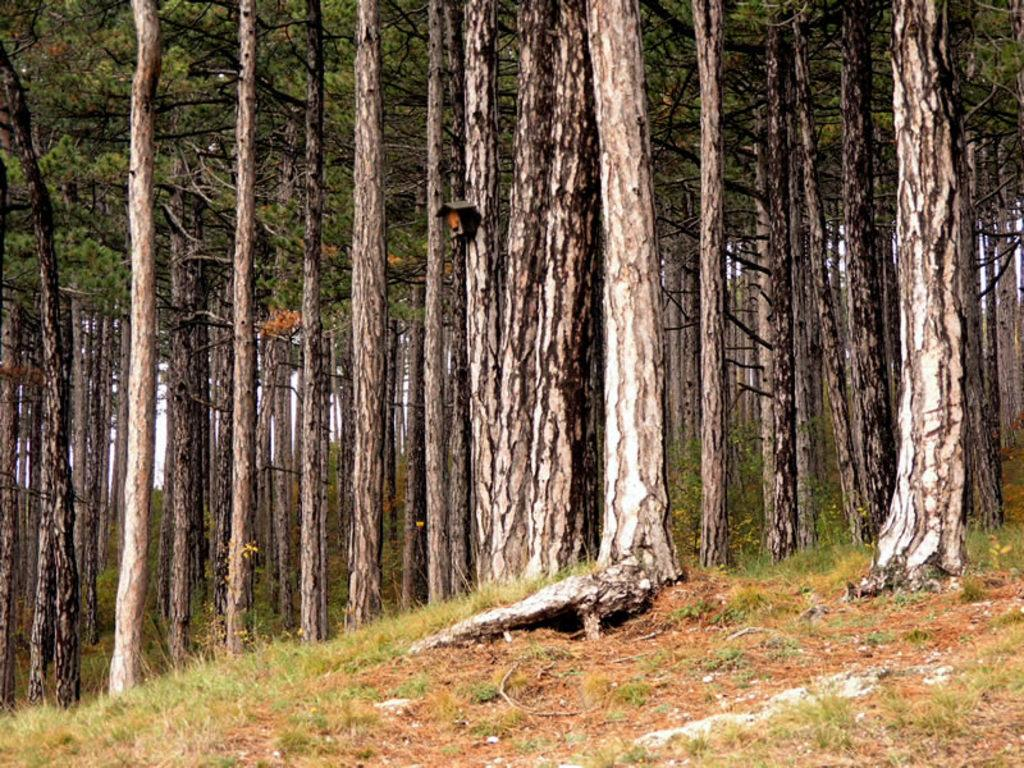What type of vegetation can be seen in the image? There is grass and trees in the image. Can you describe the natural environment depicted in the image? The image features grass and trees, which suggests a natural outdoor setting. What type of furniture is visible in the image? There is no furniture present in the image; it features grass and trees. How does the image make you feel? The image itself does not evoke a feeling, as it is a static representation of grass and trees. 